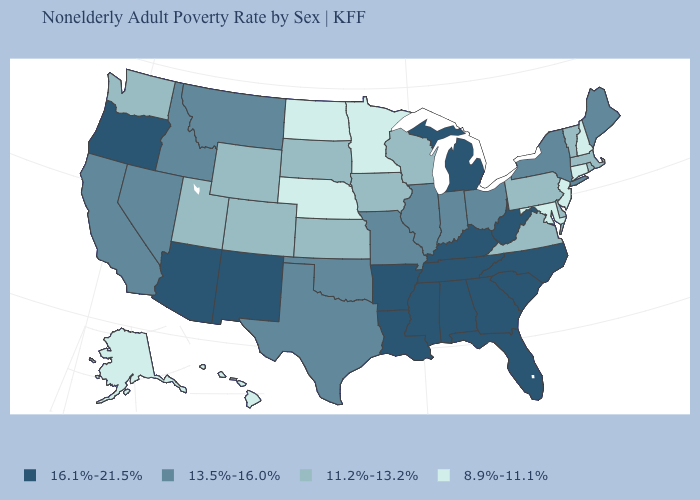What is the lowest value in the MidWest?
Concise answer only. 8.9%-11.1%. Among the states that border New Jersey , does Delaware have the highest value?
Concise answer only. No. Which states have the lowest value in the USA?
Be succinct. Alaska, Connecticut, Hawaii, Maryland, Minnesota, Nebraska, New Hampshire, New Jersey, North Dakota. How many symbols are there in the legend?
Give a very brief answer. 4. Name the states that have a value in the range 13.5%-16.0%?
Be succinct. California, Idaho, Illinois, Indiana, Maine, Missouri, Montana, Nevada, New York, Ohio, Oklahoma, Texas. Does the map have missing data?
Write a very short answer. No. What is the value of Minnesota?
Concise answer only. 8.9%-11.1%. What is the lowest value in the USA?
Answer briefly. 8.9%-11.1%. Does the map have missing data?
Write a very short answer. No. What is the value of North Carolina?
Give a very brief answer. 16.1%-21.5%. Name the states that have a value in the range 16.1%-21.5%?
Write a very short answer. Alabama, Arizona, Arkansas, Florida, Georgia, Kentucky, Louisiana, Michigan, Mississippi, New Mexico, North Carolina, Oregon, South Carolina, Tennessee, West Virginia. Does the first symbol in the legend represent the smallest category?
Give a very brief answer. No. Which states hav the highest value in the West?
Be succinct. Arizona, New Mexico, Oregon. Does the map have missing data?
Write a very short answer. No. What is the highest value in states that border Vermont?
Short answer required. 13.5%-16.0%. 